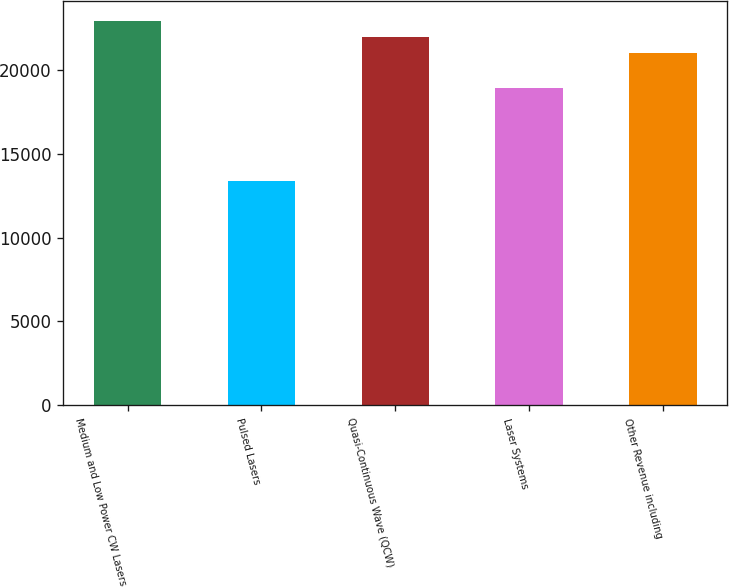Convert chart to OTSL. <chart><loc_0><loc_0><loc_500><loc_500><bar_chart><fcel>Medium and Low Power CW Lasers<fcel>Pulsed Lasers<fcel>Quasi-Continuous Wave (QCW)<fcel>Laser Systems<fcel>Other Revenue including<nl><fcel>22944.8<fcel>13347<fcel>21985.4<fcel>18920<fcel>21026<nl></chart> 